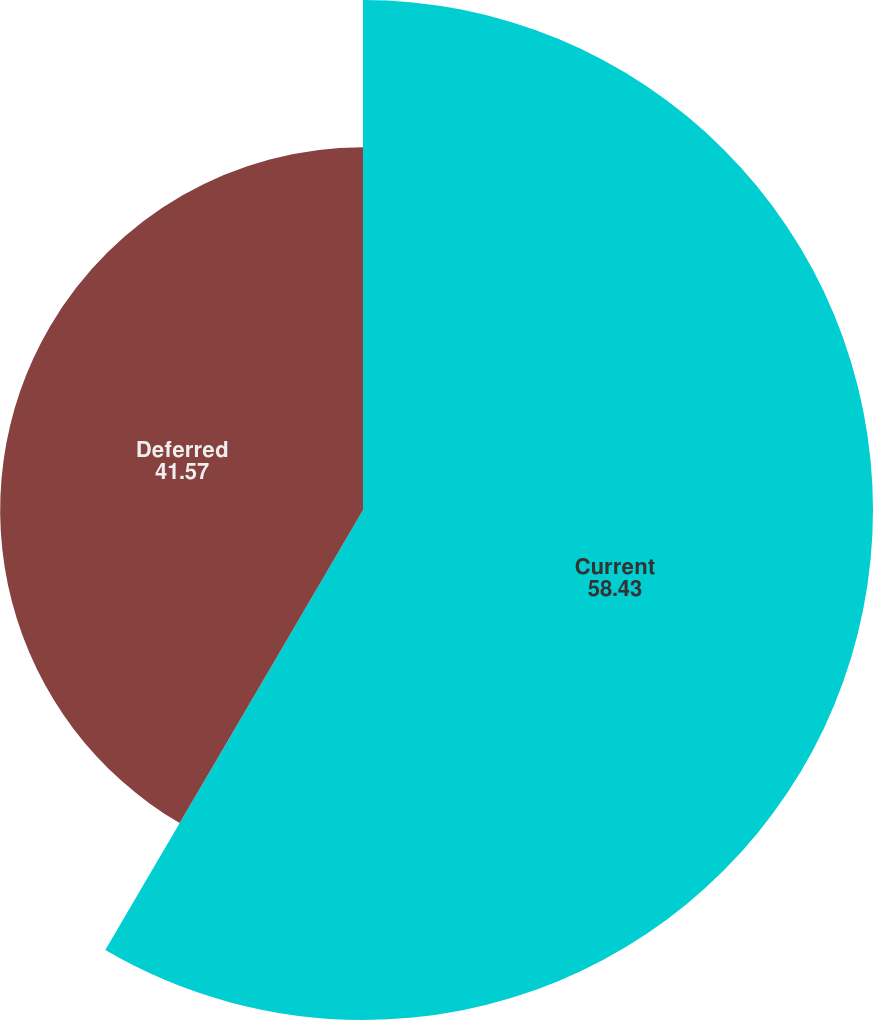Convert chart to OTSL. <chart><loc_0><loc_0><loc_500><loc_500><pie_chart><fcel>Current<fcel>Deferred<nl><fcel>58.43%<fcel>41.57%<nl></chart> 